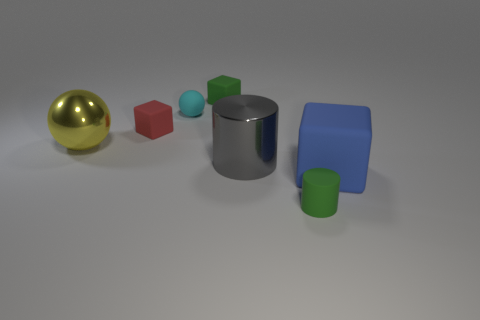Subtract all small red cubes. How many cubes are left? 2 Subtract all green cylinders. How many cylinders are left? 1 Subtract 1 cylinders. How many cylinders are left? 1 Add 1 big yellow objects. How many objects exist? 8 Subtract all red balls. How many green cylinders are left? 1 Add 3 red rubber blocks. How many red rubber blocks are left? 4 Add 4 cylinders. How many cylinders exist? 6 Subtract 1 green cylinders. How many objects are left? 6 Subtract all spheres. How many objects are left? 5 Subtract all brown balls. Subtract all red cylinders. How many balls are left? 2 